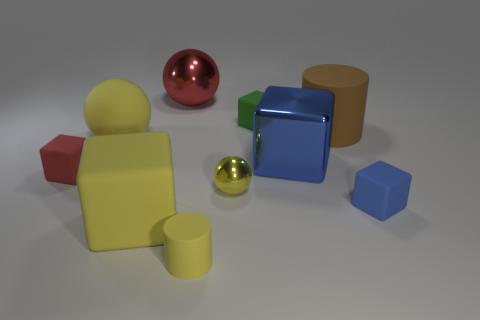The tiny matte block that is on the left side of the yellow cylinder is what color? The small matte block situated to the left of the yellow cylinder exhibits a vibrant red hue. It stands out due to its distinct matte finish contrasting with the reflective nature of other objects in the vicinity. 